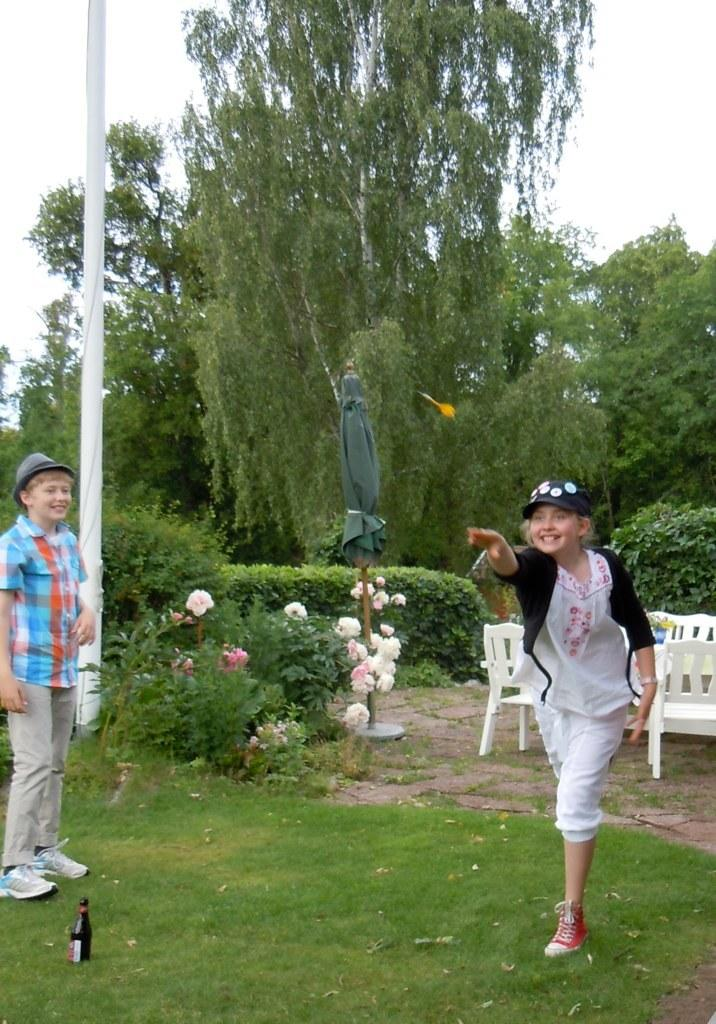How many children are in the image? There are two children in the image. What type of furniture can be seen in the image? There are white chairs visible in the image. What type of natural elements are present in the image? There are trees in the image. What type of object can be used for drinking? There is a bottle in the image. What type of object can be used for protection from the sun or rain? There is an umbrella in the image. What type of object can be used for support or stability? There is a pole in the image. What is the color of the sky in the image? The sky appears to be white in color. What type of secretary can be seen working in the image? There is no secretary present in the image. What type of bait is being used to catch fish in the image? There is no fishing or bait present in the image. 